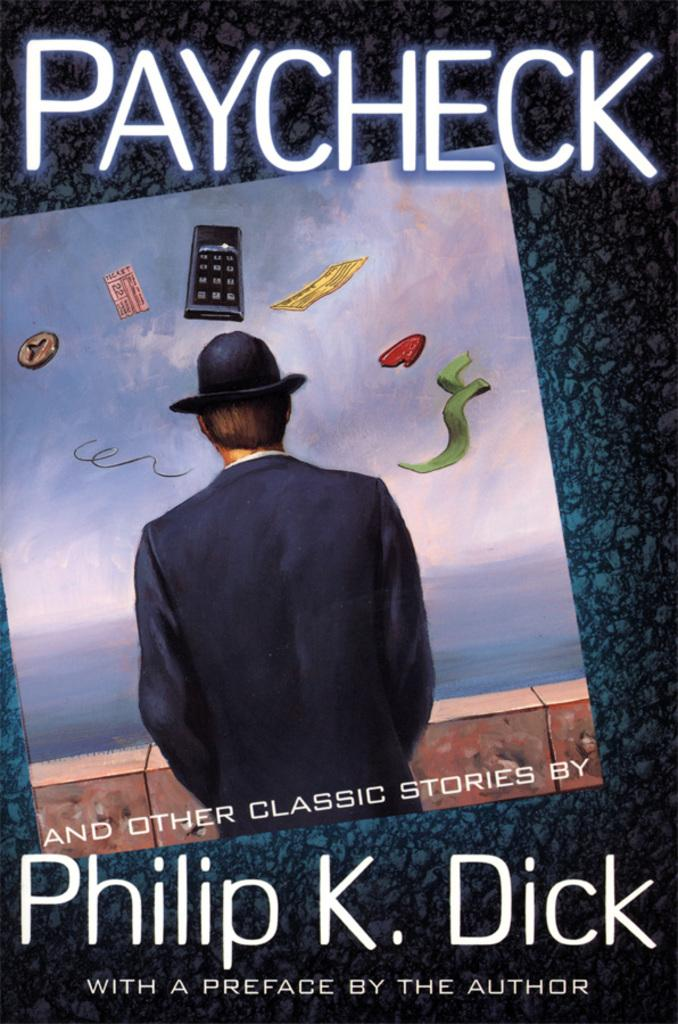<image>
Give a short and clear explanation of the subsequent image. A book cover shows that it was written by Philip K. Dick. 